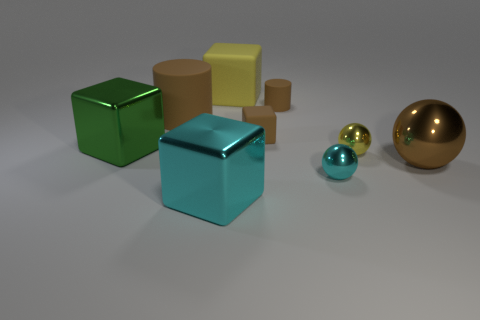Is the shape of the big yellow object the same as the green metal object?
Provide a short and direct response. Yes. What size is the green object?
Your answer should be compact. Large. Is there a tiny matte thing of the same color as the small cylinder?
Provide a short and direct response. Yes. How many big objects are red metal things or yellow things?
Offer a very short reply. 1. There is a brown object that is right of the brown cube and behind the small yellow thing; what size is it?
Your answer should be very brief. Small. How many brown rubber cylinders are left of the yellow matte cube?
Your response must be concise. 1. There is a tiny object that is both in front of the tiny brown cylinder and behind the yellow metal thing; what shape is it?
Your answer should be compact. Cube. There is a small cube that is the same color as the small matte cylinder; what is it made of?
Your answer should be very brief. Rubber. How many cylinders are either small yellow metal things or yellow matte objects?
Your answer should be very brief. 0. What is the size of the matte block that is the same color as the large metal ball?
Provide a short and direct response. Small. 